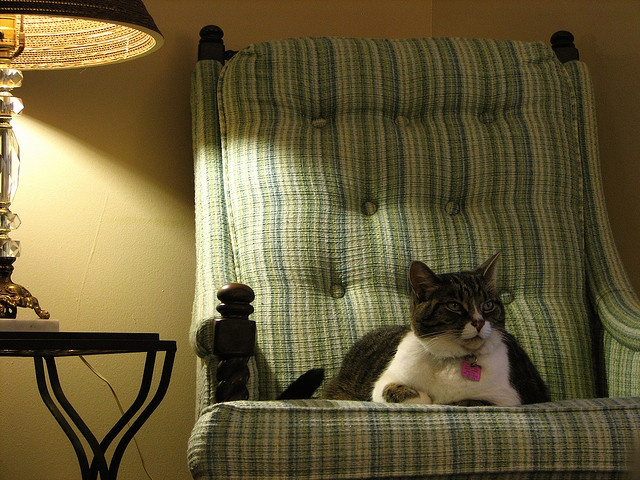Describe the objects in this image and their specific colors. I can see chair in maroon, darkgreen, black, gray, and olive tones and cat in maroon, black, olive, and gray tones in this image. 